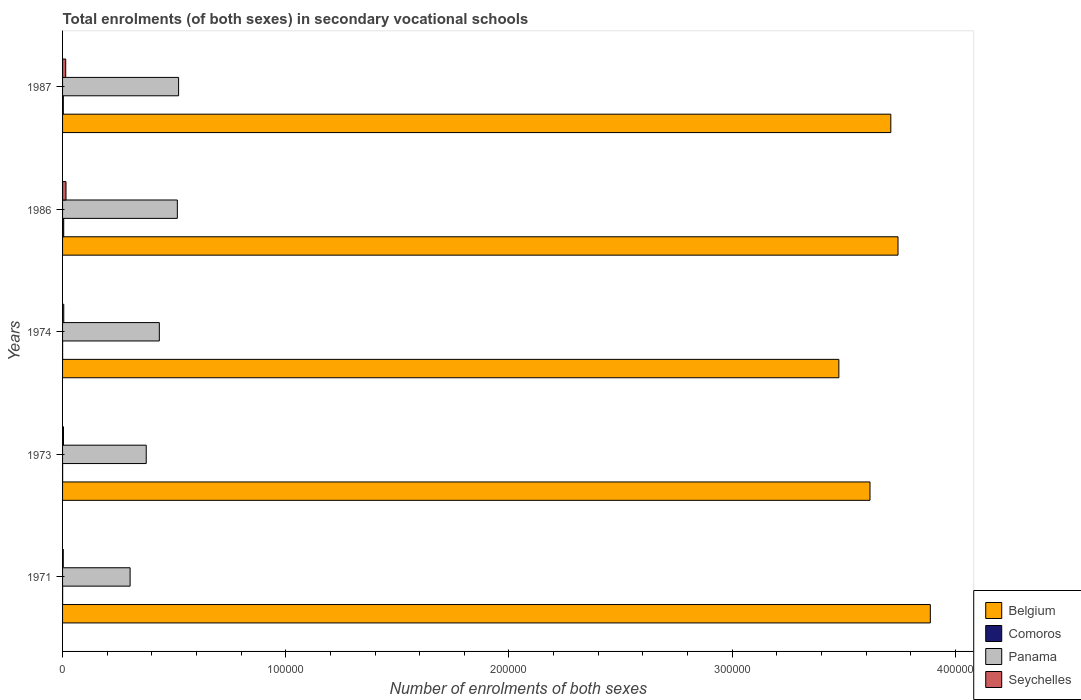How many groups of bars are there?
Keep it short and to the point. 5. Are the number of bars per tick equal to the number of legend labels?
Offer a very short reply. Yes. How many bars are there on the 4th tick from the bottom?
Your answer should be compact. 4. What is the label of the 3rd group of bars from the top?
Keep it short and to the point. 1974. In how many cases, is the number of bars for a given year not equal to the number of legend labels?
Keep it short and to the point. 0. What is the number of enrolments in secondary schools in Panama in 1987?
Give a very brief answer. 5.20e+04. Across all years, what is the maximum number of enrolments in secondary schools in Belgium?
Offer a very short reply. 3.89e+05. Across all years, what is the minimum number of enrolments in secondary schools in Comoros?
Provide a succinct answer. 22. In which year was the number of enrolments in secondary schools in Comoros minimum?
Offer a very short reply. 1974. What is the total number of enrolments in secondary schools in Comoros in the graph?
Provide a short and direct response. 918. What is the difference between the number of enrolments in secondary schools in Seychelles in 1974 and that in 1987?
Provide a short and direct response. -872. What is the difference between the number of enrolments in secondary schools in Seychelles in 1987 and the number of enrolments in secondary schools in Panama in 1973?
Your answer should be very brief. -3.61e+04. What is the average number of enrolments in secondary schools in Comoros per year?
Ensure brevity in your answer.  183.6. In the year 1987, what is the difference between the number of enrolments in secondary schools in Panama and number of enrolments in secondary schools in Comoros?
Provide a short and direct response. 5.17e+04. What is the ratio of the number of enrolments in secondary schools in Seychelles in 1974 to that in 1986?
Your response must be concise. 0.35. Is the number of enrolments in secondary schools in Belgium in 1971 less than that in 1974?
Your answer should be very brief. No. What is the difference between the highest and the second highest number of enrolments in secondary schools in Panama?
Make the answer very short. 561. What is the difference between the highest and the lowest number of enrolments in secondary schools in Comoros?
Ensure brevity in your answer.  493. In how many years, is the number of enrolments in secondary schools in Belgium greater than the average number of enrolments in secondary schools in Belgium taken over all years?
Make the answer very short. 3. Is the sum of the number of enrolments in secondary schools in Comoros in 1974 and 1987 greater than the maximum number of enrolments in secondary schools in Seychelles across all years?
Ensure brevity in your answer.  No. Is it the case that in every year, the sum of the number of enrolments in secondary schools in Panama and number of enrolments in secondary schools in Belgium is greater than the sum of number of enrolments in secondary schools in Comoros and number of enrolments in secondary schools in Seychelles?
Offer a very short reply. Yes. What does the 3rd bar from the top in 1987 represents?
Offer a terse response. Comoros. What does the 3rd bar from the bottom in 1974 represents?
Offer a terse response. Panama. Is it the case that in every year, the sum of the number of enrolments in secondary schools in Belgium and number of enrolments in secondary schools in Comoros is greater than the number of enrolments in secondary schools in Panama?
Offer a terse response. Yes. How many years are there in the graph?
Provide a succinct answer. 5. Are the values on the major ticks of X-axis written in scientific E-notation?
Make the answer very short. No. Where does the legend appear in the graph?
Your answer should be very brief. Bottom right. How many legend labels are there?
Your response must be concise. 4. How are the legend labels stacked?
Offer a terse response. Vertical. What is the title of the graph?
Keep it short and to the point. Total enrolments (of both sexes) in secondary vocational schools. Does "China" appear as one of the legend labels in the graph?
Offer a terse response. No. What is the label or title of the X-axis?
Make the answer very short. Number of enrolments of both sexes. What is the Number of enrolments of both sexes in Belgium in 1971?
Ensure brevity in your answer.  3.89e+05. What is the Number of enrolments of both sexes in Comoros in 1971?
Provide a short and direct response. 24. What is the Number of enrolments of both sexes of Panama in 1971?
Provide a short and direct response. 3.03e+04. What is the Number of enrolments of both sexes of Seychelles in 1971?
Provide a succinct answer. 312. What is the Number of enrolments of both sexes of Belgium in 1973?
Make the answer very short. 3.62e+05. What is the Number of enrolments of both sexes of Panama in 1973?
Give a very brief answer. 3.75e+04. What is the Number of enrolments of both sexes in Seychelles in 1973?
Your response must be concise. 418. What is the Number of enrolments of both sexes in Belgium in 1974?
Make the answer very short. 3.48e+05. What is the Number of enrolments of both sexes in Panama in 1974?
Offer a terse response. 4.34e+04. What is the Number of enrolments of both sexes of Seychelles in 1974?
Ensure brevity in your answer.  540. What is the Number of enrolments of both sexes of Belgium in 1986?
Your response must be concise. 3.74e+05. What is the Number of enrolments of both sexes of Comoros in 1986?
Your answer should be very brief. 515. What is the Number of enrolments of both sexes in Panama in 1986?
Give a very brief answer. 5.14e+04. What is the Number of enrolments of both sexes of Seychelles in 1986?
Your response must be concise. 1541. What is the Number of enrolments of both sexes of Belgium in 1987?
Offer a terse response. 3.71e+05. What is the Number of enrolments of both sexes of Comoros in 1987?
Keep it short and to the point. 334. What is the Number of enrolments of both sexes in Panama in 1987?
Provide a succinct answer. 5.20e+04. What is the Number of enrolments of both sexes in Seychelles in 1987?
Provide a short and direct response. 1412. Across all years, what is the maximum Number of enrolments of both sexes in Belgium?
Give a very brief answer. 3.89e+05. Across all years, what is the maximum Number of enrolments of both sexes of Comoros?
Your answer should be very brief. 515. Across all years, what is the maximum Number of enrolments of both sexes in Panama?
Provide a succinct answer. 5.20e+04. Across all years, what is the maximum Number of enrolments of both sexes of Seychelles?
Provide a succinct answer. 1541. Across all years, what is the minimum Number of enrolments of both sexes of Belgium?
Offer a very short reply. 3.48e+05. Across all years, what is the minimum Number of enrolments of both sexes of Panama?
Give a very brief answer. 3.03e+04. Across all years, what is the minimum Number of enrolments of both sexes of Seychelles?
Offer a very short reply. 312. What is the total Number of enrolments of both sexes of Belgium in the graph?
Ensure brevity in your answer.  1.84e+06. What is the total Number of enrolments of both sexes of Comoros in the graph?
Provide a succinct answer. 918. What is the total Number of enrolments of both sexes in Panama in the graph?
Your answer should be compact. 2.15e+05. What is the total Number of enrolments of both sexes in Seychelles in the graph?
Give a very brief answer. 4223. What is the difference between the Number of enrolments of both sexes in Belgium in 1971 and that in 1973?
Offer a terse response. 2.70e+04. What is the difference between the Number of enrolments of both sexes in Panama in 1971 and that in 1973?
Make the answer very short. -7224. What is the difference between the Number of enrolments of both sexes of Seychelles in 1971 and that in 1973?
Keep it short and to the point. -106. What is the difference between the Number of enrolments of both sexes in Belgium in 1971 and that in 1974?
Your answer should be very brief. 4.10e+04. What is the difference between the Number of enrolments of both sexes in Panama in 1971 and that in 1974?
Offer a very short reply. -1.31e+04. What is the difference between the Number of enrolments of both sexes of Seychelles in 1971 and that in 1974?
Offer a terse response. -228. What is the difference between the Number of enrolments of both sexes of Belgium in 1971 and that in 1986?
Your answer should be very brief. 1.45e+04. What is the difference between the Number of enrolments of both sexes in Comoros in 1971 and that in 1986?
Your answer should be very brief. -491. What is the difference between the Number of enrolments of both sexes of Panama in 1971 and that in 1986?
Make the answer very short. -2.12e+04. What is the difference between the Number of enrolments of both sexes of Seychelles in 1971 and that in 1986?
Ensure brevity in your answer.  -1229. What is the difference between the Number of enrolments of both sexes in Belgium in 1971 and that in 1987?
Give a very brief answer. 1.77e+04. What is the difference between the Number of enrolments of both sexes of Comoros in 1971 and that in 1987?
Offer a very short reply. -310. What is the difference between the Number of enrolments of both sexes in Panama in 1971 and that in 1987?
Make the answer very short. -2.17e+04. What is the difference between the Number of enrolments of both sexes of Seychelles in 1971 and that in 1987?
Your answer should be compact. -1100. What is the difference between the Number of enrolments of both sexes in Belgium in 1973 and that in 1974?
Keep it short and to the point. 1.40e+04. What is the difference between the Number of enrolments of both sexes of Panama in 1973 and that in 1974?
Provide a succinct answer. -5867. What is the difference between the Number of enrolments of both sexes of Seychelles in 1973 and that in 1974?
Ensure brevity in your answer.  -122. What is the difference between the Number of enrolments of both sexes of Belgium in 1973 and that in 1986?
Offer a terse response. -1.26e+04. What is the difference between the Number of enrolments of both sexes of Comoros in 1973 and that in 1986?
Ensure brevity in your answer.  -492. What is the difference between the Number of enrolments of both sexes in Panama in 1973 and that in 1986?
Your answer should be very brief. -1.39e+04. What is the difference between the Number of enrolments of both sexes of Seychelles in 1973 and that in 1986?
Your response must be concise. -1123. What is the difference between the Number of enrolments of both sexes of Belgium in 1973 and that in 1987?
Provide a succinct answer. -9328. What is the difference between the Number of enrolments of both sexes of Comoros in 1973 and that in 1987?
Provide a short and direct response. -311. What is the difference between the Number of enrolments of both sexes of Panama in 1973 and that in 1987?
Give a very brief answer. -1.45e+04. What is the difference between the Number of enrolments of both sexes of Seychelles in 1973 and that in 1987?
Your response must be concise. -994. What is the difference between the Number of enrolments of both sexes in Belgium in 1974 and that in 1986?
Your response must be concise. -2.65e+04. What is the difference between the Number of enrolments of both sexes in Comoros in 1974 and that in 1986?
Make the answer very short. -493. What is the difference between the Number of enrolments of both sexes in Panama in 1974 and that in 1986?
Your answer should be compact. -8071. What is the difference between the Number of enrolments of both sexes in Seychelles in 1974 and that in 1986?
Give a very brief answer. -1001. What is the difference between the Number of enrolments of both sexes of Belgium in 1974 and that in 1987?
Keep it short and to the point. -2.33e+04. What is the difference between the Number of enrolments of both sexes in Comoros in 1974 and that in 1987?
Ensure brevity in your answer.  -312. What is the difference between the Number of enrolments of both sexes in Panama in 1974 and that in 1987?
Make the answer very short. -8632. What is the difference between the Number of enrolments of both sexes of Seychelles in 1974 and that in 1987?
Your answer should be compact. -872. What is the difference between the Number of enrolments of both sexes of Belgium in 1986 and that in 1987?
Your answer should be compact. 3223. What is the difference between the Number of enrolments of both sexes in Comoros in 1986 and that in 1987?
Offer a terse response. 181. What is the difference between the Number of enrolments of both sexes of Panama in 1986 and that in 1987?
Give a very brief answer. -561. What is the difference between the Number of enrolments of both sexes of Seychelles in 1986 and that in 1987?
Offer a terse response. 129. What is the difference between the Number of enrolments of both sexes of Belgium in 1971 and the Number of enrolments of both sexes of Comoros in 1973?
Give a very brief answer. 3.89e+05. What is the difference between the Number of enrolments of both sexes of Belgium in 1971 and the Number of enrolments of both sexes of Panama in 1973?
Your answer should be compact. 3.51e+05. What is the difference between the Number of enrolments of both sexes of Belgium in 1971 and the Number of enrolments of both sexes of Seychelles in 1973?
Offer a terse response. 3.88e+05. What is the difference between the Number of enrolments of both sexes of Comoros in 1971 and the Number of enrolments of both sexes of Panama in 1973?
Your answer should be compact. -3.75e+04. What is the difference between the Number of enrolments of both sexes in Comoros in 1971 and the Number of enrolments of both sexes in Seychelles in 1973?
Your answer should be very brief. -394. What is the difference between the Number of enrolments of both sexes of Panama in 1971 and the Number of enrolments of both sexes of Seychelles in 1973?
Offer a very short reply. 2.98e+04. What is the difference between the Number of enrolments of both sexes in Belgium in 1971 and the Number of enrolments of both sexes in Comoros in 1974?
Provide a succinct answer. 3.89e+05. What is the difference between the Number of enrolments of both sexes in Belgium in 1971 and the Number of enrolments of both sexes in Panama in 1974?
Your response must be concise. 3.45e+05. What is the difference between the Number of enrolments of both sexes in Belgium in 1971 and the Number of enrolments of both sexes in Seychelles in 1974?
Keep it short and to the point. 3.88e+05. What is the difference between the Number of enrolments of both sexes in Comoros in 1971 and the Number of enrolments of both sexes in Panama in 1974?
Make the answer very short. -4.33e+04. What is the difference between the Number of enrolments of both sexes in Comoros in 1971 and the Number of enrolments of both sexes in Seychelles in 1974?
Your response must be concise. -516. What is the difference between the Number of enrolments of both sexes of Panama in 1971 and the Number of enrolments of both sexes of Seychelles in 1974?
Offer a terse response. 2.97e+04. What is the difference between the Number of enrolments of both sexes in Belgium in 1971 and the Number of enrolments of both sexes in Comoros in 1986?
Your response must be concise. 3.88e+05. What is the difference between the Number of enrolments of both sexes of Belgium in 1971 and the Number of enrolments of both sexes of Panama in 1986?
Give a very brief answer. 3.37e+05. What is the difference between the Number of enrolments of both sexes in Belgium in 1971 and the Number of enrolments of both sexes in Seychelles in 1986?
Provide a succinct answer. 3.87e+05. What is the difference between the Number of enrolments of both sexes in Comoros in 1971 and the Number of enrolments of both sexes in Panama in 1986?
Ensure brevity in your answer.  -5.14e+04. What is the difference between the Number of enrolments of both sexes of Comoros in 1971 and the Number of enrolments of both sexes of Seychelles in 1986?
Ensure brevity in your answer.  -1517. What is the difference between the Number of enrolments of both sexes of Panama in 1971 and the Number of enrolments of both sexes of Seychelles in 1986?
Keep it short and to the point. 2.87e+04. What is the difference between the Number of enrolments of both sexes of Belgium in 1971 and the Number of enrolments of both sexes of Comoros in 1987?
Your answer should be very brief. 3.88e+05. What is the difference between the Number of enrolments of both sexes in Belgium in 1971 and the Number of enrolments of both sexes in Panama in 1987?
Provide a short and direct response. 3.37e+05. What is the difference between the Number of enrolments of both sexes of Belgium in 1971 and the Number of enrolments of both sexes of Seychelles in 1987?
Provide a succinct answer. 3.87e+05. What is the difference between the Number of enrolments of both sexes in Comoros in 1971 and the Number of enrolments of both sexes in Panama in 1987?
Your response must be concise. -5.20e+04. What is the difference between the Number of enrolments of both sexes in Comoros in 1971 and the Number of enrolments of both sexes in Seychelles in 1987?
Your answer should be compact. -1388. What is the difference between the Number of enrolments of both sexes of Panama in 1971 and the Number of enrolments of both sexes of Seychelles in 1987?
Give a very brief answer. 2.89e+04. What is the difference between the Number of enrolments of both sexes in Belgium in 1973 and the Number of enrolments of both sexes in Comoros in 1974?
Offer a very short reply. 3.62e+05. What is the difference between the Number of enrolments of both sexes in Belgium in 1973 and the Number of enrolments of both sexes in Panama in 1974?
Provide a succinct answer. 3.18e+05. What is the difference between the Number of enrolments of both sexes in Belgium in 1973 and the Number of enrolments of both sexes in Seychelles in 1974?
Your answer should be compact. 3.61e+05. What is the difference between the Number of enrolments of both sexes of Comoros in 1973 and the Number of enrolments of both sexes of Panama in 1974?
Your answer should be compact. -4.33e+04. What is the difference between the Number of enrolments of both sexes in Comoros in 1973 and the Number of enrolments of both sexes in Seychelles in 1974?
Provide a succinct answer. -517. What is the difference between the Number of enrolments of both sexes of Panama in 1973 and the Number of enrolments of both sexes of Seychelles in 1974?
Provide a short and direct response. 3.69e+04. What is the difference between the Number of enrolments of both sexes in Belgium in 1973 and the Number of enrolments of both sexes in Comoros in 1986?
Your answer should be compact. 3.61e+05. What is the difference between the Number of enrolments of both sexes of Belgium in 1973 and the Number of enrolments of both sexes of Panama in 1986?
Give a very brief answer. 3.10e+05. What is the difference between the Number of enrolments of both sexes of Belgium in 1973 and the Number of enrolments of both sexes of Seychelles in 1986?
Your response must be concise. 3.60e+05. What is the difference between the Number of enrolments of both sexes in Comoros in 1973 and the Number of enrolments of both sexes in Panama in 1986?
Make the answer very short. -5.14e+04. What is the difference between the Number of enrolments of both sexes of Comoros in 1973 and the Number of enrolments of both sexes of Seychelles in 1986?
Provide a succinct answer. -1518. What is the difference between the Number of enrolments of both sexes of Panama in 1973 and the Number of enrolments of both sexes of Seychelles in 1986?
Offer a very short reply. 3.59e+04. What is the difference between the Number of enrolments of both sexes of Belgium in 1973 and the Number of enrolments of both sexes of Comoros in 1987?
Give a very brief answer. 3.61e+05. What is the difference between the Number of enrolments of both sexes in Belgium in 1973 and the Number of enrolments of both sexes in Panama in 1987?
Provide a succinct answer. 3.10e+05. What is the difference between the Number of enrolments of both sexes of Belgium in 1973 and the Number of enrolments of both sexes of Seychelles in 1987?
Provide a succinct answer. 3.60e+05. What is the difference between the Number of enrolments of both sexes in Comoros in 1973 and the Number of enrolments of both sexes in Panama in 1987?
Keep it short and to the point. -5.20e+04. What is the difference between the Number of enrolments of both sexes in Comoros in 1973 and the Number of enrolments of both sexes in Seychelles in 1987?
Make the answer very short. -1389. What is the difference between the Number of enrolments of both sexes of Panama in 1973 and the Number of enrolments of both sexes of Seychelles in 1987?
Make the answer very short. 3.61e+04. What is the difference between the Number of enrolments of both sexes of Belgium in 1974 and the Number of enrolments of both sexes of Comoros in 1986?
Ensure brevity in your answer.  3.47e+05. What is the difference between the Number of enrolments of both sexes of Belgium in 1974 and the Number of enrolments of both sexes of Panama in 1986?
Provide a succinct answer. 2.96e+05. What is the difference between the Number of enrolments of both sexes of Belgium in 1974 and the Number of enrolments of both sexes of Seychelles in 1986?
Your answer should be compact. 3.46e+05. What is the difference between the Number of enrolments of both sexes of Comoros in 1974 and the Number of enrolments of both sexes of Panama in 1986?
Give a very brief answer. -5.14e+04. What is the difference between the Number of enrolments of both sexes in Comoros in 1974 and the Number of enrolments of both sexes in Seychelles in 1986?
Make the answer very short. -1519. What is the difference between the Number of enrolments of both sexes of Panama in 1974 and the Number of enrolments of both sexes of Seychelles in 1986?
Provide a short and direct response. 4.18e+04. What is the difference between the Number of enrolments of both sexes of Belgium in 1974 and the Number of enrolments of both sexes of Comoros in 1987?
Ensure brevity in your answer.  3.47e+05. What is the difference between the Number of enrolments of both sexes of Belgium in 1974 and the Number of enrolments of both sexes of Panama in 1987?
Offer a very short reply. 2.96e+05. What is the difference between the Number of enrolments of both sexes in Belgium in 1974 and the Number of enrolments of both sexes in Seychelles in 1987?
Your answer should be compact. 3.46e+05. What is the difference between the Number of enrolments of both sexes of Comoros in 1974 and the Number of enrolments of both sexes of Panama in 1987?
Offer a terse response. -5.20e+04. What is the difference between the Number of enrolments of both sexes of Comoros in 1974 and the Number of enrolments of both sexes of Seychelles in 1987?
Your answer should be very brief. -1390. What is the difference between the Number of enrolments of both sexes in Panama in 1974 and the Number of enrolments of both sexes in Seychelles in 1987?
Provide a succinct answer. 4.19e+04. What is the difference between the Number of enrolments of both sexes in Belgium in 1986 and the Number of enrolments of both sexes in Comoros in 1987?
Give a very brief answer. 3.74e+05. What is the difference between the Number of enrolments of both sexes in Belgium in 1986 and the Number of enrolments of both sexes in Panama in 1987?
Make the answer very short. 3.22e+05. What is the difference between the Number of enrolments of both sexes of Belgium in 1986 and the Number of enrolments of both sexes of Seychelles in 1987?
Make the answer very short. 3.73e+05. What is the difference between the Number of enrolments of both sexes of Comoros in 1986 and the Number of enrolments of both sexes of Panama in 1987?
Make the answer very short. -5.15e+04. What is the difference between the Number of enrolments of both sexes of Comoros in 1986 and the Number of enrolments of both sexes of Seychelles in 1987?
Offer a very short reply. -897. What is the difference between the Number of enrolments of both sexes in Panama in 1986 and the Number of enrolments of both sexes in Seychelles in 1987?
Keep it short and to the point. 5.00e+04. What is the average Number of enrolments of both sexes of Belgium per year?
Keep it short and to the point. 3.69e+05. What is the average Number of enrolments of both sexes in Comoros per year?
Keep it short and to the point. 183.6. What is the average Number of enrolments of both sexes of Panama per year?
Your response must be concise. 4.29e+04. What is the average Number of enrolments of both sexes of Seychelles per year?
Your answer should be very brief. 844.6. In the year 1971, what is the difference between the Number of enrolments of both sexes in Belgium and Number of enrolments of both sexes in Comoros?
Your response must be concise. 3.89e+05. In the year 1971, what is the difference between the Number of enrolments of both sexes in Belgium and Number of enrolments of both sexes in Panama?
Keep it short and to the point. 3.59e+05. In the year 1971, what is the difference between the Number of enrolments of both sexes in Belgium and Number of enrolments of both sexes in Seychelles?
Offer a very short reply. 3.88e+05. In the year 1971, what is the difference between the Number of enrolments of both sexes of Comoros and Number of enrolments of both sexes of Panama?
Offer a terse response. -3.02e+04. In the year 1971, what is the difference between the Number of enrolments of both sexes of Comoros and Number of enrolments of both sexes of Seychelles?
Make the answer very short. -288. In the year 1971, what is the difference between the Number of enrolments of both sexes in Panama and Number of enrolments of both sexes in Seychelles?
Provide a succinct answer. 3.00e+04. In the year 1973, what is the difference between the Number of enrolments of both sexes in Belgium and Number of enrolments of both sexes in Comoros?
Provide a short and direct response. 3.62e+05. In the year 1973, what is the difference between the Number of enrolments of both sexes in Belgium and Number of enrolments of both sexes in Panama?
Offer a very short reply. 3.24e+05. In the year 1973, what is the difference between the Number of enrolments of both sexes of Belgium and Number of enrolments of both sexes of Seychelles?
Keep it short and to the point. 3.61e+05. In the year 1973, what is the difference between the Number of enrolments of both sexes of Comoros and Number of enrolments of both sexes of Panama?
Offer a very short reply. -3.75e+04. In the year 1973, what is the difference between the Number of enrolments of both sexes in Comoros and Number of enrolments of both sexes in Seychelles?
Offer a terse response. -395. In the year 1973, what is the difference between the Number of enrolments of both sexes of Panama and Number of enrolments of both sexes of Seychelles?
Provide a short and direct response. 3.71e+04. In the year 1974, what is the difference between the Number of enrolments of both sexes of Belgium and Number of enrolments of both sexes of Comoros?
Offer a terse response. 3.48e+05. In the year 1974, what is the difference between the Number of enrolments of both sexes of Belgium and Number of enrolments of both sexes of Panama?
Offer a very short reply. 3.04e+05. In the year 1974, what is the difference between the Number of enrolments of both sexes in Belgium and Number of enrolments of both sexes in Seychelles?
Your response must be concise. 3.47e+05. In the year 1974, what is the difference between the Number of enrolments of both sexes of Comoros and Number of enrolments of both sexes of Panama?
Your response must be concise. -4.33e+04. In the year 1974, what is the difference between the Number of enrolments of both sexes of Comoros and Number of enrolments of both sexes of Seychelles?
Keep it short and to the point. -518. In the year 1974, what is the difference between the Number of enrolments of both sexes in Panama and Number of enrolments of both sexes in Seychelles?
Offer a terse response. 4.28e+04. In the year 1986, what is the difference between the Number of enrolments of both sexes in Belgium and Number of enrolments of both sexes in Comoros?
Offer a terse response. 3.74e+05. In the year 1986, what is the difference between the Number of enrolments of both sexes in Belgium and Number of enrolments of both sexes in Panama?
Keep it short and to the point. 3.23e+05. In the year 1986, what is the difference between the Number of enrolments of both sexes of Belgium and Number of enrolments of both sexes of Seychelles?
Make the answer very short. 3.73e+05. In the year 1986, what is the difference between the Number of enrolments of both sexes in Comoros and Number of enrolments of both sexes in Panama?
Give a very brief answer. -5.09e+04. In the year 1986, what is the difference between the Number of enrolments of both sexes of Comoros and Number of enrolments of both sexes of Seychelles?
Your answer should be compact. -1026. In the year 1986, what is the difference between the Number of enrolments of both sexes in Panama and Number of enrolments of both sexes in Seychelles?
Offer a terse response. 4.99e+04. In the year 1987, what is the difference between the Number of enrolments of both sexes of Belgium and Number of enrolments of both sexes of Comoros?
Provide a succinct answer. 3.71e+05. In the year 1987, what is the difference between the Number of enrolments of both sexes in Belgium and Number of enrolments of both sexes in Panama?
Your response must be concise. 3.19e+05. In the year 1987, what is the difference between the Number of enrolments of both sexes of Belgium and Number of enrolments of both sexes of Seychelles?
Keep it short and to the point. 3.70e+05. In the year 1987, what is the difference between the Number of enrolments of both sexes in Comoros and Number of enrolments of both sexes in Panama?
Give a very brief answer. -5.17e+04. In the year 1987, what is the difference between the Number of enrolments of both sexes in Comoros and Number of enrolments of both sexes in Seychelles?
Provide a short and direct response. -1078. In the year 1987, what is the difference between the Number of enrolments of both sexes in Panama and Number of enrolments of both sexes in Seychelles?
Your answer should be very brief. 5.06e+04. What is the ratio of the Number of enrolments of both sexes in Belgium in 1971 to that in 1973?
Provide a short and direct response. 1.07. What is the ratio of the Number of enrolments of both sexes in Comoros in 1971 to that in 1973?
Your answer should be very brief. 1.04. What is the ratio of the Number of enrolments of both sexes of Panama in 1971 to that in 1973?
Ensure brevity in your answer.  0.81. What is the ratio of the Number of enrolments of both sexes in Seychelles in 1971 to that in 1973?
Offer a terse response. 0.75. What is the ratio of the Number of enrolments of both sexes of Belgium in 1971 to that in 1974?
Offer a terse response. 1.12. What is the ratio of the Number of enrolments of both sexes in Comoros in 1971 to that in 1974?
Provide a short and direct response. 1.09. What is the ratio of the Number of enrolments of both sexes in Panama in 1971 to that in 1974?
Your response must be concise. 0.7. What is the ratio of the Number of enrolments of both sexes in Seychelles in 1971 to that in 1974?
Ensure brevity in your answer.  0.58. What is the ratio of the Number of enrolments of both sexes in Belgium in 1971 to that in 1986?
Provide a succinct answer. 1.04. What is the ratio of the Number of enrolments of both sexes of Comoros in 1971 to that in 1986?
Offer a very short reply. 0.05. What is the ratio of the Number of enrolments of both sexes in Panama in 1971 to that in 1986?
Offer a very short reply. 0.59. What is the ratio of the Number of enrolments of both sexes of Seychelles in 1971 to that in 1986?
Your answer should be very brief. 0.2. What is the ratio of the Number of enrolments of both sexes of Belgium in 1971 to that in 1987?
Provide a succinct answer. 1.05. What is the ratio of the Number of enrolments of both sexes in Comoros in 1971 to that in 1987?
Make the answer very short. 0.07. What is the ratio of the Number of enrolments of both sexes in Panama in 1971 to that in 1987?
Offer a very short reply. 0.58. What is the ratio of the Number of enrolments of both sexes of Seychelles in 1971 to that in 1987?
Offer a very short reply. 0.22. What is the ratio of the Number of enrolments of both sexes in Belgium in 1973 to that in 1974?
Give a very brief answer. 1.04. What is the ratio of the Number of enrolments of both sexes of Comoros in 1973 to that in 1974?
Make the answer very short. 1.05. What is the ratio of the Number of enrolments of both sexes in Panama in 1973 to that in 1974?
Provide a short and direct response. 0.86. What is the ratio of the Number of enrolments of both sexes of Seychelles in 1973 to that in 1974?
Your response must be concise. 0.77. What is the ratio of the Number of enrolments of both sexes in Belgium in 1973 to that in 1986?
Make the answer very short. 0.97. What is the ratio of the Number of enrolments of both sexes of Comoros in 1973 to that in 1986?
Ensure brevity in your answer.  0.04. What is the ratio of the Number of enrolments of both sexes of Panama in 1973 to that in 1986?
Offer a terse response. 0.73. What is the ratio of the Number of enrolments of both sexes in Seychelles in 1973 to that in 1986?
Your response must be concise. 0.27. What is the ratio of the Number of enrolments of both sexes in Belgium in 1973 to that in 1987?
Give a very brief answer. 0.97. What is the ratio of the Number of enrolments of both sexes in Comoros in 1973 to that in 1987?
Give a very brief answer. 0.07. What is the ratio of the Number of enrolments of both sexes of Panama in 1973 to that in 1987?
Your answer should be very brief. 0.72. What is the ratio of the Number of enrolments of both sexes of Seychelles in 1973 to that in 1987?
Your answer should be compact. 0.3. What is the ratio of the Number of enrolments of both sexes in Belgium in 1974 to that in 1986?
Your answer should be very brief. 0.93. What is the ratio of the Number of enrolments of both sexes in Comoros in 1974 to that in 1986?
Keep it short and to the point. 0.04. What is the ratio of the Number of enrolments of both sexes in Panama in 1974 to that in 1986?
Your answer should be very brief. 0.84. What is the ratio of the Number of enrolments of both sexes of Seychelles in 1974 to that in 1986?
Keep it short and to the point. 0.35. What is the ratio of the Number of enrolments of both sexes of Belgium in 1974 to that in 1987?
Provide a short and direct response. 0.94. What is the ratio of the Number of enrolments of both sexes in Comoros in 1974 to that in 1987?
Your answer should be compact. 0.07. What is the ratio of the Number of enrolments of both sexes of Panama in 1974 to that in 1987?
Your answer should be very brief. 0.83. What is the ratio of the Number of enrolments of both sexes of Seychelles in 1974 to that in 1987?
Provide a succinct answer. 0.38. What is the ratio of the Number of enrolments of both sexes in Belgium in 1986 to that in 1987?
Provide a short and direct response. 1.01. What is the ratio of the Number of enrolments of both sexes in Comoros in 1986 to that in 1987?
Keep it short and to the point. 1.54. What is the ratio of the Number of enrolments of both sexes of Seychelles in 1986 to that in 1987?
Your answer should be very brief. 1.09. What is the difference between the highest and the second highest Number of enrolments of both sexes in Belgium?
Give a very brief answer. 1.45e+04. What is the difference between the highest and the second highest Number of enrolments of both sexes in Comoros?
Provide a succinct answer. 181. What is the difference between the highest and the second highest Number of enrolments of both sexes in Panama?
Your response must be concise. 561. What is the difference between the highest and the second highest Number of enrolments of both sexes in Seychelles?
Your answer should be compact. 129. What is the difference between the highest and the lowest Number of enrolments of both sexes in Belgium?
Provide a succinct answer. 4.10e+04. What is the difference between the highest and the lowest Number of enrolments of both sexes in Comoros?
Provide a succinct answer. 493. What is the difference between the highest and the lowest Number of enrolments of both sexes in Panama?
Offer a very short reply. 2.17e+04. What is the difference between the highest and the lowest Number of enrolments of both sexes of Seychelles?
Provide a short and direct response. 1229. 